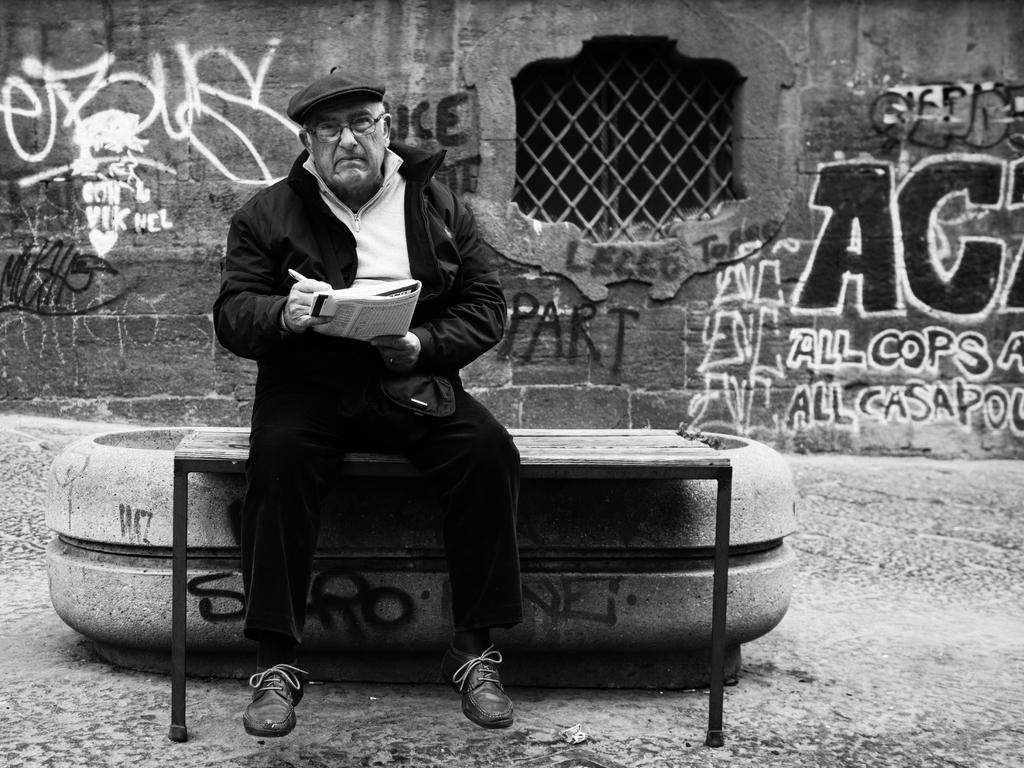Please provide a concise description of this image. This is a black and white image. We can see a person wearing a cap is holding an object and sitting. We can see a bench. We can see the ground with an object. We can see the wall with some text. We can also see a window with grill. 